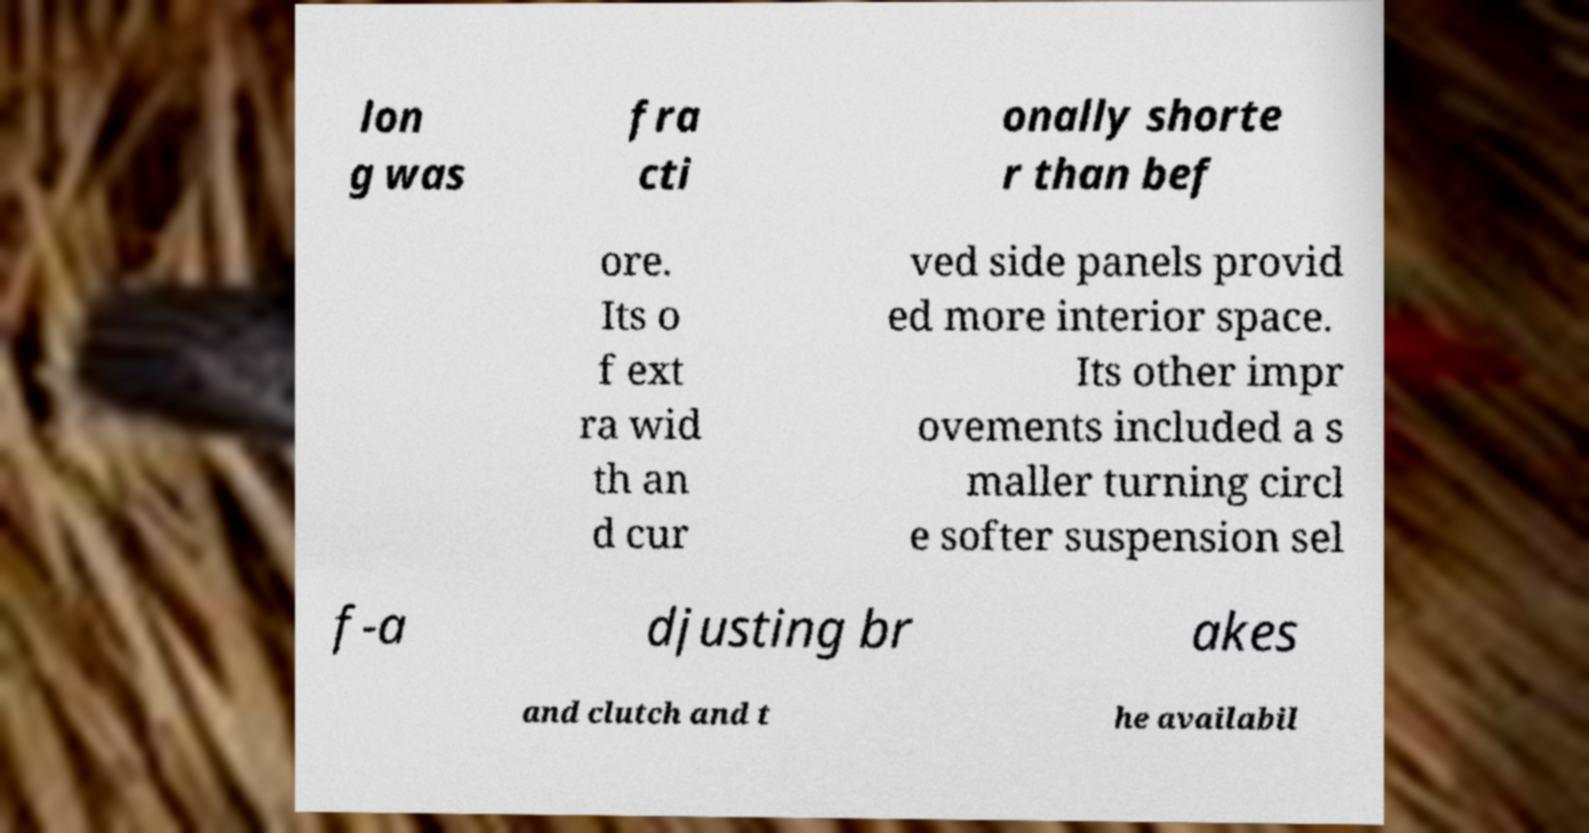Please read and relay the text visible in this image. What does it say? lon g was fra cti onally shorte r than bef ore. Its o f ext ra wid th an d cur ved side panels provid ed more interior space. Its other impr ovements included a s maller turning circl e softer suspension sel f-a djusting br akes and clutch and t he availabil 